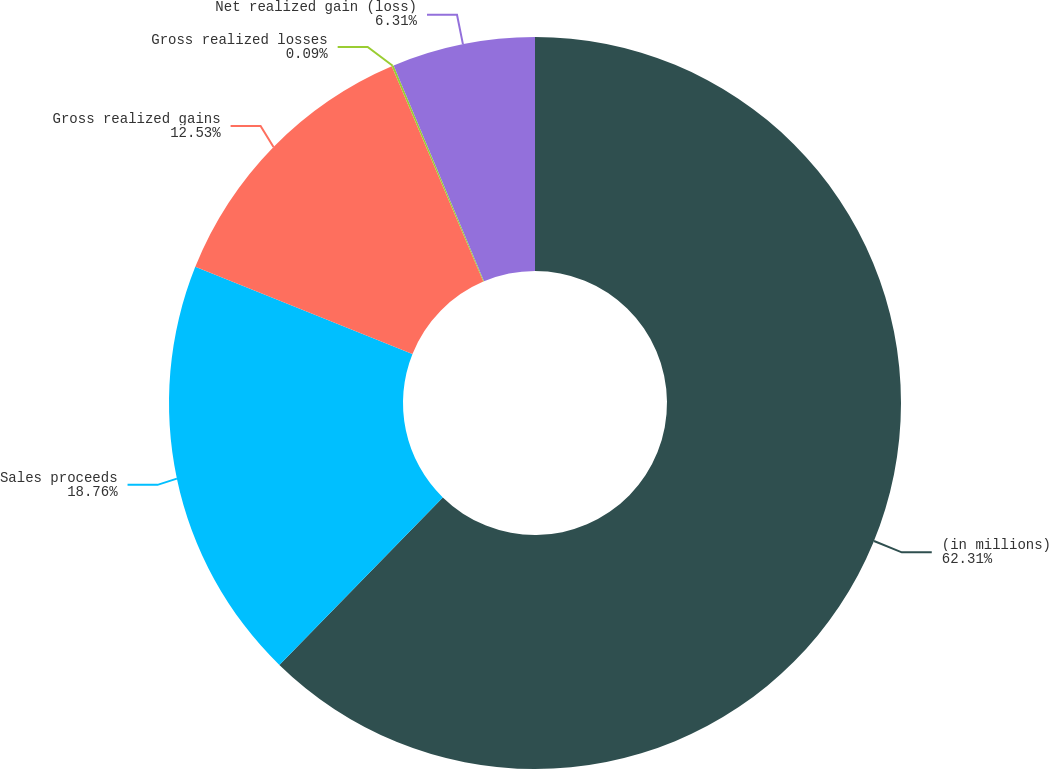Convert chart. <chart><loc_0><loc_0><loc_500><loc_500><pie_chart><fcel>(in millions)<fcel>Sales proceeds<fcel>Gross realized gains<fcel>Gross realized losses<fcel>Net realized gain (loss)<nl><fcel>62.3%<fcel>18.76%<fcel>12.53%<fcel>0.09%<fcel>6.31%<nl></chart> 